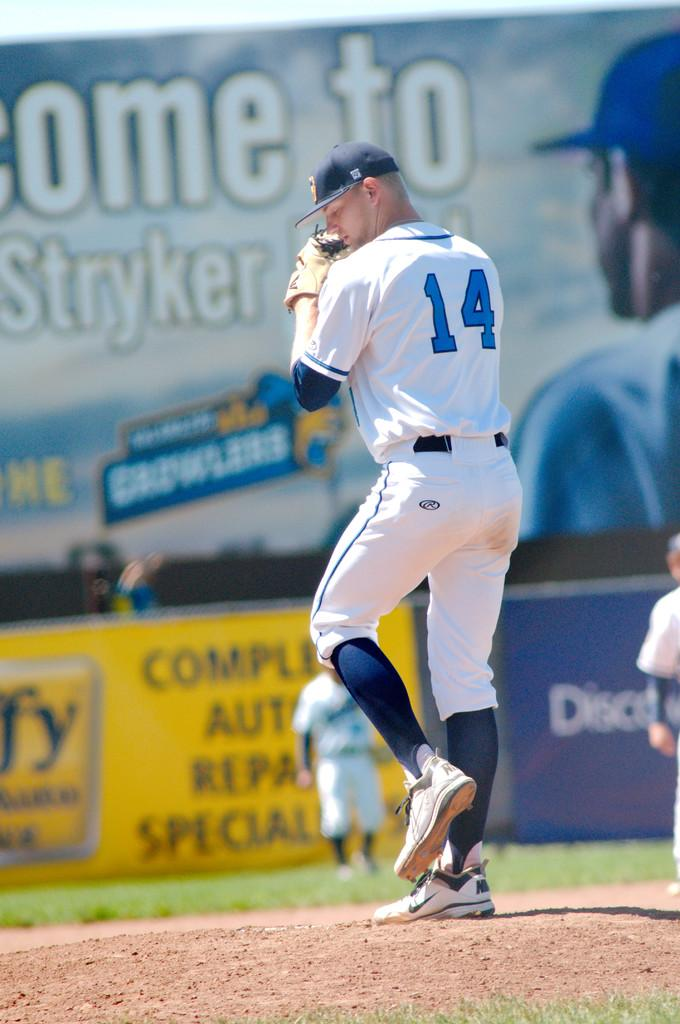<image>
Offer a succinct explanation of the picture presented. Baseball player number 14 stands in a position ready to throw the ball with a "Come to Stryker" advertisment prominently displayed behind him. 